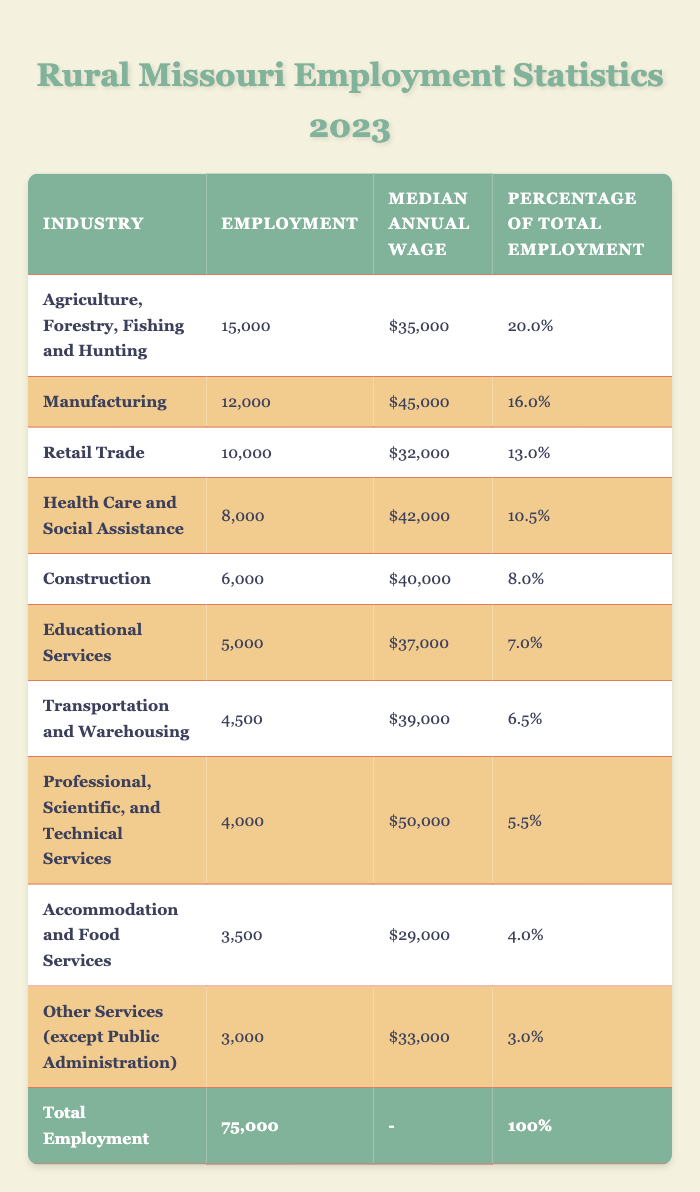What is the total employment in rural Missouri for 2023? The total employment is explicitly listed in the last row of the table, which states that the total employment is 75,000.
Answer: 75,000 Which industry has the highest percentage of total employment? According to the table, the industry with the highest percentage of total employment is Agriculture, Forestry, Fishing and Hunting, with a percentage of 20.0%.
Answer: Agriculture, Forestry, Fishing and Hunting What is the median annual wage for the Manufacturing industry? The table lists the median annual wage for the Manufacturing industry as $45,000.
Answer: $45,000 How many people are employed in Health Care and Social Assistance? The table shows that the Health Care and Social Assistance industry has 8,000 people employed.
Answer: 8,000 Which industry has the lowest employment number? The industry with the lowest employment number, according to the table, is Other Services (except Public Administration), which has 3,000 employed.
Answer: Other Services (except Public Administration) If we combine the employment numbers of Retail Trade and Accommodation and Food Services, what is the total? The employment number for Retail Trade is 10,000 and for Accommodation and Food Services is 3,500, so their sum is 10,000 + 3,500 = 13,500.
Answer: 13,500 Is the median annual wage for Professional, Scientific, and Technical Services higher than that of Educational Services? The median annual wage for Professional, Scientific, and Technical Services is $50,000, while Educational Services is $37,000. Since $50,000 is greater than $37,000, the statement is true.
Answer: Yes What percentage of total employment does Construction represent? The table shows that Construction represents 8.0% of total employment in rural Missouri.
Answer: 8.0% Which industry has a median annual wage closest to the overall average of the listed industries? To find the overall average, sum the median wages: (35,000 + 45,000 + 32,000 + 42,000 + 40,000 + 37,000 + 39,000 + 50,000 + 29,000 + 33,000) =  450,000; divide by 10 (the number of industries): 450,000 / 10 = 45,000. The closest median is for Manufacturing at $45,000.
Answer: Manufacturing How much more employment does Agriculture, Forestry, Fishing and Hunting have than Transportation and Warehousing? Agriculture, Forestry, Fishing and Hunting has 15,000 employed, and Transportation and Warehousing has 4,500. The difference is 15,000 - 4,500 = 10,500.
Answer: 10,500 